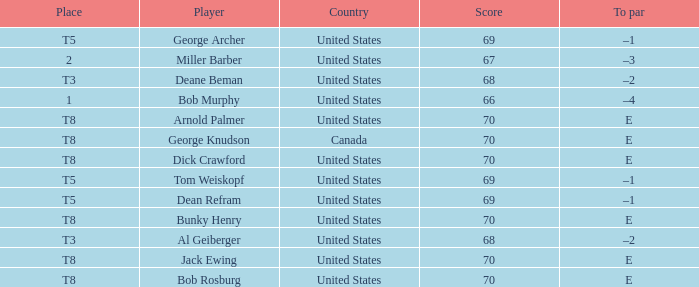Which country is George Archer from? United States. 